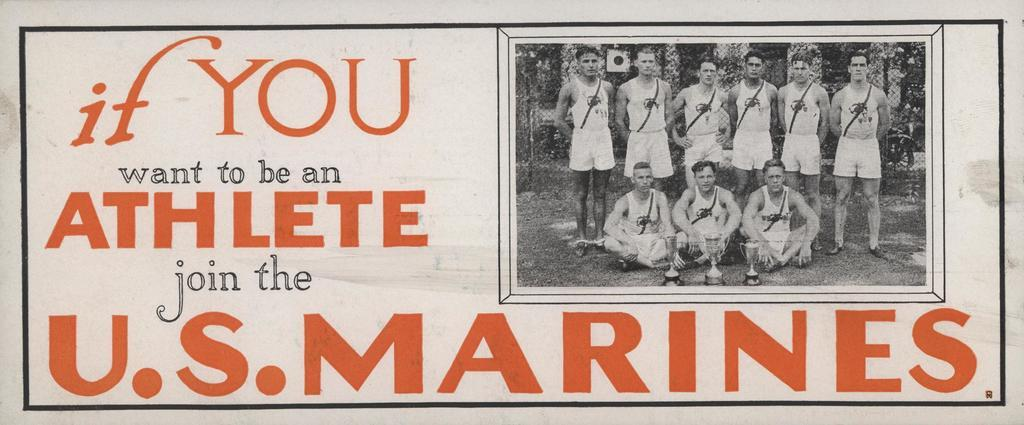Provide a one-sentence caption for the provided image. A sign stating if you want to be an athlete join the U.S. Marines. 